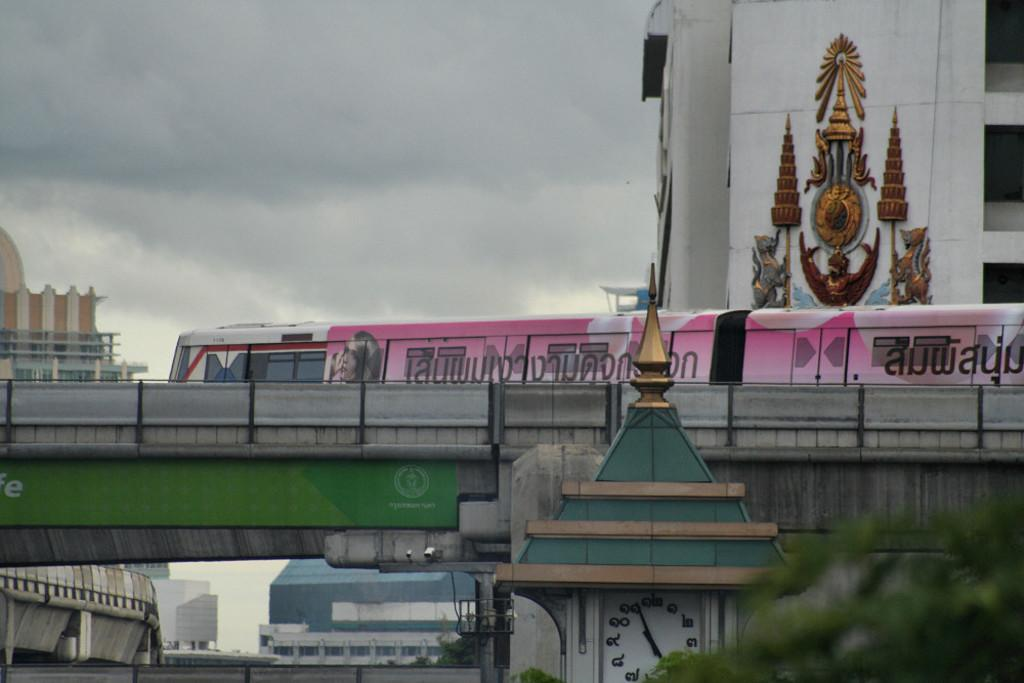What is located in the bottom right of the image? There is a tree and a clock tower in the bottom right of the image. What can be seen in the background of the image? There is a bridge, a train, buildings, and the sky visible in the background of the image. What type of structure is the train on? The train is on a bridge in the background of the image. What is the color of the sky in the image? The sky is visible in the background of the image, but the color is not specified in the provided facts. What type of metal is the tree made of in the image? There is no information about the tree being made of metal in the image. Trees are typically made of wood and not metal. 